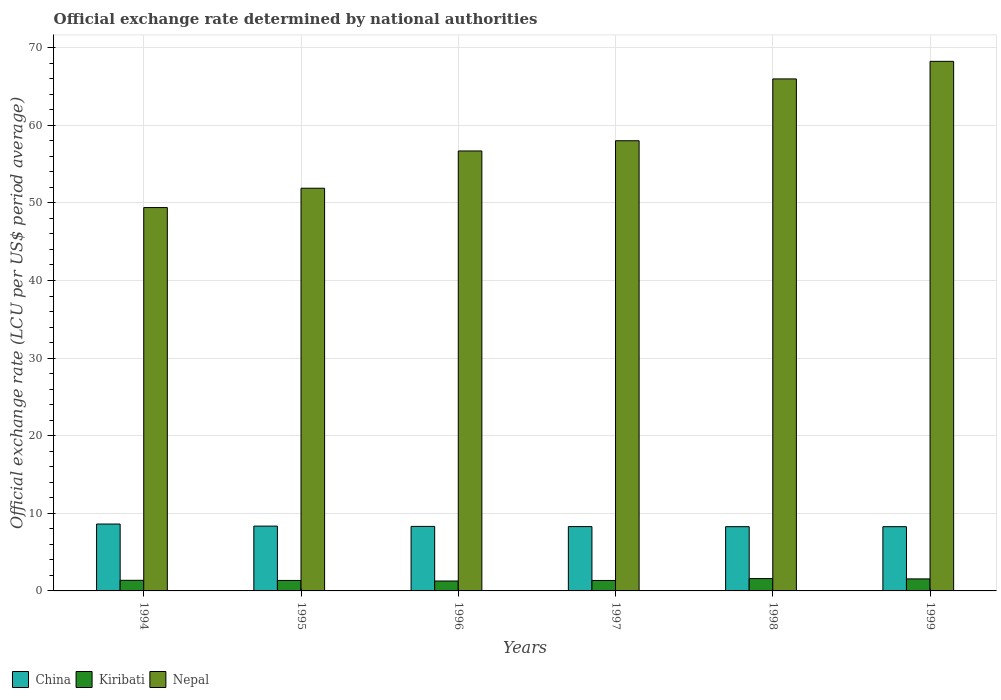How many different coloured bars are there?
Provide a succinct answer. 3. Are the number of bars on each tick of the X-axis equal?
Keep it short and to the point. Yes. How many bars are there on the 4th tick from the right?
Your answer should be very brief. 3. What is the official exchange rate in Kiribati in 1998?
Your response must be concise. 1.59. Across all years, what is the maximum official exchange rate in China?
Provide a short and direct response. 8.62. Across all years, what is the minimum official exchange rate in China?
Offer a very short reply. 8.28. In which year was the official exchange rate in Kiribati maximum?
Offer a very short reply. 1998. What is the total official exchange rate in China in the graph?
Give a very brief answer. 50.13. What is the difference between the official exchange rate in Kiribati in 1994 and that in 1998?
Give a very brief answer. -0.22. What is the difference between the official exchange rate in Kiribati in 1998 and the official exchange rate in Nepal in 1996?
Your answer should be compact. -55.1. What is the average official exchange rate in Nepal per year?
Keep it short and to the point. 58.37. In the year 1996, what is the difference between the official exchange rate in China and official exchange rate in Kiribati?
Your answer should be very brief. 7.04. What is the ratio of the official exchange rate in Nepal in 1995 to that in 1997?
Offer a terse response. 0.89. What is the difference between the highest and the second highest official exchange rate in Kiribati?
Ensure brevity in your answer.  0.04. What is the difference between the highest and the lowest official exchange rate in Kiribati?
Provide a succinct answer. 0.31. What does the 2nd bar from the left in 1994 represents?
Your answer should be compact. Kiribati. What does the 1st bar from the right in 1994 represents?
Provide a succinct answer. Nepal. Is it the case that in every year, the sum of the official exchange rate in Kiribati and official exchange rate in Nepal is greater than the official exchange rate in China?
Provide a succinct answer. Yes. How many bars are there?
Keep it short and to the point. 18. What is the difference between two consecutive major ticks on the Y-axis?
Offer a terse response. 10. Are the values on the major ticks of Y-axis written in scientific E-notation?
Provide a succinct answer. No. Does the graph contain any zero values?
Provide a short and direct response. No. Where does the legend appear in the graph?
Keep it short and to the point. Bottom left. How many legend labels are there?
Your answer should be compact. 3. What is the title of the graph?
Provide a short and direct response. Official exchange rate determined by national authorities. Does "Philippines" appear as one of the legend labels in the graph?
Make the answer very short. No. What is the label or title of the X-axis?
Offer a very short reply. Years. What is the label or title of the Y-axis?
Offer a very short reply. Official exchange rate (LCU per US$ period average). What is the Official exchange rate (LCU per US$ period average) of China in 1994?
Ensure brevity in your answer.  8.62. What is the Official exchange rate (LCU per US$ period average) of Kiribati in 1994?
Your answer should be compact. 1.37. What is the Official exchange rate (LCU per US$ period average) in Nepal in 1994?
Your answer should be very brief. 49.4. What is the Official exchange rate (LCU per US$ period average) in China in 1995?
Offer a terse response. 8.35. What is the Official exchange rate (LCU per US$ period average) in Kiribati in 1995?
Your answer should be very brief. 1.35. What is the Official exchange rate (LCU per US$ period average) in Nepal in 1995?
Offer a very short reply. 51.89. What is the Official exchange rate (LCU per US$ period average) of China in 1996?
Give a very brief answer. 8.31. What is the Official exchange rate (LCU per US$ period average) of Kiribati in 1996?
Offer a terse response. 1.28. What is the Official exchange rate (LCU per US$ period average) in Nepal in 1996?
Make the answer very short. 56.69. What is the Official exchange rate (LCU per US$ period average) in China in 1997?
Offer a terse response. 8.29. What is the Official exchange rate (LCU per US$ period average) in Kiribati in 1997?
Provide a short and direct response. 1.35. What is the Official exchange rate (LCU per US$ period average) of Nepal in 1997?
Your answer should be very brief. 58.01. What is the Official exchange rate (LCU per US$ period average) in China in 1998?
Keep it short and to the point. 8.28. What is the Official exchange rate (LCU per US$ period average) of Kiribati in 1998?
Provide a succinct answer. 1.59. What is the Official exchange rate (LCU per US$ period average) of Nepal in 1998?
Keep it short and to the point. 65.98. What is the Official exchange rate (LCU per US$ period average) in China in 1999?
Keep it short and to the point. 8.28. What is the Official exchange rate (LCU per US$ period average) in Kiribati in 1999?
Make the answer very short. 1.55. What is the Official exchange rate (LCU per US$ period average) of Nepal in 1999?
Ensure brevity in your answer.  68.24. Across all years, what is the maximum Official exchange rate (LCU per US$ period average) in China?
Keep it short and to the point. 8.62. Across all years, what is the maximum Official exchange rate (LCU per US$ period average) of Kiribati?
Make the answer very short. 1.59. Across all years, what is the maximum Official exchange rate (LCU per US$ period average) in Nepal?
Your response must be concise. 68.24. Across all years, what is the minimum Official exchange rate (LCU per US$ period average) of China?
Your answer should be compact. 8.28. Across all years, what is the minimum Official exchange rate (LCU per US$ period average) in Kiribati?
Provide a succinct answer. 1.28. Across all years, what is the minimum Official exchange rate (LCU per US$ period average) of Nepal?
Provide a succinct answer. 49.4. What is the total Official exchange rate (LCU per US$ period average) of China in the graph?
Provide a short and direct response. 50.13. What is the total Official exchange rate (LCU per US$ period average) in Kiribati in the graph?
Offer a terse response. 8.48. What is the total Official exchange rate (LCU per US$ period average) of Nepal in the graph?
Your answer should be compact. 350.2. What is the difference between the Official exchange rate (LCU per US$ period average) of China in 1994 and that in 1995?
Your response must be concise. 0.27. What is the difference between the Official exchange rate (LCU per US$ period average) of Kiribati in 1994 and that in 1995?
Offer a very short reply. 0.02. What is the difference between the Official exchange rate (LCU per US$ period average) of Nepal in 1994 and that in 1995?
Ensure brevity in your answer.  -2.49. What is the difference between the Official exchange rate (LCU per US$ period average) in China in 1994 and that in 1996?
Provide a short and direct response. 0.3. What is the difference between the Official exchange rate (LCU per US$ period average) of Kiribati in 1994 and that in 1996?
Your answer should be very brief. 0.09. What is the difference between the Official exchange rate (LCU per US$ period average) of Nepal in 1994 and that in 1996?
Give a very brief answer. -7.29. What is the difference between the Official exchange rate (LCU per US$ period average) in China in 1994 and that in 1997?
Your answer should be very brief. 0.33. What is the difference between the Official exchange rate (LCU per US$ period average) in Kiribati in 1994 and that in 1997?
Your answer should be compact. 0.02. What is the difference between the Official exchange rate (LCU per US$ period average) of Nepal in 1994 and that in 1997?
Make the answer very short. -8.61. What is the difference between the Official exchange rate (LCU per US$ period average) in China in 1994 and that in 1998?
Offer a terse response. 0.34. What is the difference between the Official exchange rate (LCU per US$ period average) of Kiribati in 1994 and that in 1998?
Offer a very short reply. -0.22. What is the difference between the Official exchange rate (LCU per US$ period average) of Nepal in 1994 and that in 1998?
Your answer should be very brief. -16.58. What is the difference between the Official exchange rate (LCU per US$ period average) of China in 1994 and that in 1999?
Offer a very short reply. 0.34. What is the difference between the Official exchange rate (LCU per US$ period average) of Kiribati in 1994 and that in 1999?
Make the answer very short. -0.18. What is the difference between the Official exchange rate (LCU per US$ period average) of Nepal in 1994 and that in 1999?
Your response must be concise. -18.84. What is the difference between the Official exchange rate (LCU per US$ period average) in China in 1995 and that in 1996?
Provide a succinct answer. 0.04. What is the difference between the Official exchange rate (LCU per US$ period average) in Kiribati in 1995 and that in 1996?
Keep it short and to the point. 0.07. What is the difference between the Official exchange rate (LCU per US$ period average) of Nepal in 1995 and that in 1996?
Provide a succinct answer. -4.8. What is the difference between the Official exchange rate (LCU per US$ period average) in China in 1995 and that in 1997?
Provide a short and direct response. 0.06. What is the difference between the Official exchange rate (LCU per US$ period average) of Kiribati in 1995 and that in 1997?
Provide a short and direct response. 0. What is the difference between the Official exchange rate (LCU per US$ period average) in Nepal in 1995 and that in 1997?
Provide a short and direct response. -6.12. What is the difference between the Official exchange rate (LCU per US$ period average) in China in 1995 and that in 1998?
Offer a terse response. 0.07. What is the difference between the Official exchange rate (LCU per US$ period average) of Kiribati in 1995 and that in 1998?
Your answer should be very brief. -0.24. What is the difference between the Official exchange rate (LCU per US$ period average) in Nepal in 1995 and that in 1998?
Offer a very short reply. -14.09. What is the difference between the Official exchange rate (LCU per US$ period average) in China in 1995 and that in 1999?
Offer a terse response. 0.07. What is the difference between the Official exchange rate (LCU per US$ period average) in Kiribati in 1995 and that in 1999?
Your response must be concise. -0.2. What is the difference between the Official exchange rate (LCU per US$ period average) of Nepal in 1995 and that in 1999?
Your answer should be compact. -16.35. What is the difference between the Official exchange rate (LCU per US$ period average) in China in 1996 and that in 1997?
Your response must be concise. 0.02. What is the difference between the Official exchange rate (LCU per US$ period average) of Kiribati in 1996 and that in 1997?
Keep it short and to the point. -0.07. What is the difference between the Official exchange rate (LCU per US$ period average) in Nepal in 1996 and that in 1997?
Ensure brevity in your answer.  -1.32. What is the difference between the Official exchange rate (LCU per US$ period average) of China in 1996 and that in 1998?
Provide a succinct answer. 0.04. What is the difference between the Official exchange rate (LCU per US$ period average) in Kiribati in 1996 and that in 1998?
Your answer should be compact. -0.31. What is the difference between the Official exchange rate (LCU per US$ period average) of Nepal in 1996 and that in 1998?
Offer a terse response. -9.28. What is the difference between the Official exchange rate (LCU per US$ period average) in China in 1996 and that in 1999?
Offer a very short reply. 0.04. What is the difference between the Official exchange rate (LCU per US$ period average) of Kiribati in 1996 and that in 1999?
Offer a terse response. -0.27. What is the difference between the Official exchange rate (LCU per US$ period average) in Nepal in 1996 and that in 1999?
Make the answer very short. -11.55. What is the difference between the Official exchange rate (LCU per US$ period average) of China in 1997 and that in 1998?
Offer a terse response. 0.01. What is the difference between the Official exchange rate (LCU per US$ period average) in Kiribati in 1997 and that in 1998?
Ensure brevity in your answer.  -0.24. What is the difference between the Official exchange rate (LCU per US$ period average) of Nepal in 1997 and that in 1998?
Your answer should be very brief. -7.97. What is the difference between the Official exchange rate (LCU per US$ period average) in China in 1997 and that in 1999?
Keep it short and to the point. 0.01. What is the difference between the Official exchange rate (LCU per US$ period average) in Kiribati in 1997 and that in 1999?
Keep it short and to the point. -0.2. What is the difference between the Official exchange rate (LCU per US$ period average) in Nepal in 1997 and that in 1999?
Your answer should be very brief. -10.23. What is the difference between the Official exchange rate (LCU per US$ period average) in China in 1998 and that in 1999?
Provide a short and direct response. 0. What is the difference between the Official exchange rate (LCU per US$ period average) in Kiribati in 1998 and that in 1999?
Offer a very short reply. 0.04. What is the difference between the Official exchange rate (LCU per US$ period average) of Nepal in 1998 and that in 1999?
Provide a short and direct response. -2.26. What is the difference between the Official exchange rate (LCU per US$ period average) in China in 1994 and the Official exchange rate (LCU per US$ period average) in Kiribati in 1995?
Offer a very short reply. 7.27. What is the difference between the Official exchange rate (LCU per US$ period average) in China in 1994 and the Official exchange rate (LCU per US$ period average) in Nepal in 1995?
Give a very brief answer. -43.27. What is the difference between the Official exchange rate (LCU per US$ period average) of Kiribati in 1994 and the Official exchange rate (LCU per US$ period average) of Nepal in 1995?
Provide a short and direct response. -50.52. What is the difference between the Official exchange rate (LCU per US$ period average) in China in 1994 and the Official exchange rate (LCU per US$ period average) in Kiribati in 1996?
Give a very brief answer. 7.34. What is the difference between the Official exchange rate (LCU per US$ period average) in China in 1994 and the Official exchange rate (LCU per US$ period average) in Nepal in 1996?
Give a very brief answer. -48.07. What is the difference between the Official exchange rate (LCU per US$ period average) of Kiribati in 1994 and the Official exchange rate (LCU per US$ period average) of Nepal in 1996?
Make the answer very short. -55.32. What is the difference between the Official exchange rate (LCU per US$ period average) of China in 1994 and the Official exchange rate (LCU per US$ period average) of Kiribati in 1997?
Offer a very short reply. 7.27. What is the difference between the Official exchange rate (LCU per US$ period average) of China in 1994 and the Official exchange rate (LCU per US$ period average) of Nepal in 1997?
Provide a short and direct response. -49.39. What is the difference between the Official exchange rate (LCU per US$ period average) of Kiribati in 1994 and the Official exchange rate (LCU per US$ period average) of Nepal in 1997?
Provide a succinct answer. -56.64. What is the difference between the Official exchange rate (LCU per US$ period average) in China in 1994 and the Official exchange rate (LCU per US$ period average) in Kiribati in 1998?
Offer a very short reply. 7.03. What is the difference between the Official exchange rate (LCU per US$ period average) in China in 1994 and the Official exchange rate (LCU per US$ period average) in Nepal in 1998?
Keep it short and to the point. -57.36. What is the difference between the Official exchange rate (LCU per US$ period average) in Kiribati in 1994 and the Official exchange rate (LCU per US$ period average) in Nepal in 1998?
Offer a very short reply. -64.61. What is the difference between the Official exchange rate (LCU per US$ period average) of China in 1994 and the Official exchange rate (LCU per US$ period average) of Kiribati in 1999?
Offer a very short reply. 7.07. What is the difference between the Official exchange rate (LCU per US$ period average) in China in 1994 and the Official exchange rate (LCU per US$ period average) in Nepal in 1999?
Make the answer very short. -59.62. What is the difference between the Official exchange rate (LCU per US$ period average) of Kiribati in 1994 and the Official exchange rate (LCU per US$ period average) of Nepal in 1999?
Your response must be concise. -66.87. What is the difference between the Official exchange rate (LCU per US$ period average) in China in 1995 and the Official exchange rate (LCU per US$ period average) in Kiribati in 1996?
Make the answer very short. 7.07. What is the difference between the Official exchange rate (LCU per US$ period average) of China in 1995 and the Official exchange rate (LCU per US$ period average) of Nepal in 1996?
Offer a very short reply. -48.34. What is the difference between the Official exchange rate (LCU per US$ period average) in Kiribati in 1995 and the Official exchange rate (LCU per US$ period average) in Nepal in 1996?
Ensure brevity in your answer.  -55.34. What is the difference between the Official exchange rate (LCU per US$ period average) in China in 1995 and the Official exchange rate (LCU per US$ period average) in Kiribati in 1997?
Provide a short and direct response. 7. What is the difference between the Official exchange rate (LCU per US$ period average) of China in 1995 and the Official exchange rate (LCU per US$ period average) of Nepal in 1997?
Provide a succinct answer. -49.66. What is the difference between the Official exchange rate (LCU per US$ period average) of Kiribati in 1995 and the Official exchange rate (LCU per US$ period average) of Nepal in 1997?
Make the answer very short. -56.66. What is the difference between the Official exchange rate (LCU per US$ period average) in China in 1995 and the Official exchange rate (LCU per US$ period average) in Kiribati in 1998?
Give a very brief answer. 6.76. What is the difference between the Official exchange rate (LCU per US$ period average) of China in 1995 and the Official exchange rate (LCU per US$ period average) of Nepal in 1998?
Offer a terse response. -57.62. What is the difference between the Official exchange rate (LCU per US$ period average) in Kiribati in 1995 and the Official exchange rate (LCU per US$ period average) in Nepal in 1998?
Your answer should be compact. -64.63. What is the difference between the Official exchange rate (LCU per US$ period average) in China in 1995 and the Official exchange rate (LCU per US$ period average) in Kiribati in 1999?
Give a very brief answer. 6.8. What is the difference between the Official exchange rate (LCU per US$ period average) of China in 1995 and the Official exchange rate (LCU per US$ period average) of Nepal in 1999?
Your answer should be very brief. -59.89. What is the difference between the Official exchange rate (LCU per US$ period average) of Kiribati in 1995 and the Official exchange rate (LCU per US$ period average) of Nepal in 1999?
Provide a short and direct response. -66.89. What is the difference between the Official exchange rate (LCU per US$ period average) of China in 1996 and the Official exchange rate (LCU per US$ period average) of Kiribati in 1997?
Give a very brief answer. 6.97. What is the difference between the Official exchange rate (LCU per US$ period average) in China in 1996 and the Official exchange rate (LCU per US$ period average) in Nepal in 1997?
Provide a short and direct response. -49.7. What is the difference between the Official exchange rate (LCU per US$ period average) of Kiribati in 1996 and the Official exchange rate (LCU per US$ period average) of Nepal in 1997?
Give a very brief answer. -56.73. What is the difference between the Official exchange rate (LCU per US$ period average) in China in 1996 and the Official exchange rate (LCU per US$ period average) in Kiribati in 1998?
Offer a terse response. 6.72. What is the difference between the Official exchange rate (LCU per US$ period average) in China in 1996 and the Official exchange rate (LCU per US$ period average) in Nepal in 1998?
Make the answer very short. -57.66. What is the difference between the Official exchange rate (LCU per US$ period average) in Kiribati in 1996 and the Official exchange rate (LCU per US$ period average) in Nepal in 1998?
Provide a succinct answer. -64.7. What is the difference between the Official exchange rate (LCU per US$ period average) in China in 1996 and the Official exchange rate (LCU per US$ period average) in Kiribati in 1999?
Make the answer very short. 6.76. What is the difference between the Official exchange rate (LCU per US$ period average) in China in 1996 and the Official exchange rate (LCU per US$ period average) in Nepal in 1999?
Offer a very short reply. -59.93. What is the difference between the Official exchange rate (LCU per US$ period average) in Kiribati in 1996 and the Official exchange rate (LCU per US$ period average) in Nepal in 1999?
Make the answer very short. -66.96. What is the difference between the Official exchange rate (LCU per US$ period average) of China in 1997 and the Official exchange rate (LCU per US$ period average) of Kiribati in 1998?
Keep it short and to the point. 6.7. What is the difference between the Official exchange rate (LCU per US$ period average) of China in 1997 and the Official exchange rate (LCU per US$ period average) of Nepal in 1998?
Provide a succinct answer. -57.69. What is the difference between the Official exchange rate (LCU per US$ period average) in Kiribati in 1997 and the Official exchange rate (LCU per US$ period average) in Nepal in 1998?
Provide a short and direct response. -64.63. What is the difference between the Official exchange rate (LCU per US$ period average) of China in 1997 and the Official exchange rate (LCU per US$ period average) of Kiribati in 1999?
Offer a terse response. 6.74. What is the difference between the Official exchange rate (LCU per US$ period average) of China in 1997 and the Official exchange rate (LCU per US$ period average) of Nepal in 1999?
Your answer should be compact. -59.95. What is the difference between the Official exchange rate (LCU per US$ period average) of Kiribati in 1997 and the Official exchange rate (LCU per US$ period average) of Nepal in 1999?
Ensure brevity in your answer.  -66.89. What is the difference between the Official exchange rate (LCU per US$ period average) in China in 1998 and the Official exchange rate (LCU per US$ period average) in Kiribati in 1999?
Your answer should be very brief. 6.73. What is the difference between the Official exchange rate (LCU per US$ period average) of China in 1998 and the Official exchange rate (LCU per US$ period average) of Nepal in 1999?
Provide a succinct answer. -59.96. What is the difference between the Official exchange rate (LCU per US$ period average) in Kiribati in 1998 and the Official exchange rate (LCU per US$ period average) in Nepal in 1999?
Ensure brevity in your answer.  -66.65. What is the average Official exchange rate (LCU per US$ period average) of China per year?
Your answer should be compact. 8.36. What is the average Official exchange rate (LCU per US$ period average) in Kiribati per year?
Provide a succinct answer. 1.41. What is the average Official exchange rate (LCU per US$ period average) of Nepal per year?
Give a very brief answer. 58.37. In the year 1994, what is the difference between the Official exchange rate (LCU per US$ period average) of China and Official exchange rate (LCU per US$ period average) of Kiribati?
Make the answer very short. 7.25. In the year 1994, what is the difference between the Official exchange rate (LCU per US$ period average) of China and Official exchange rate (LCU per US$ period average) of Nepal?
Provide a succinct answer. -40.78. In the year 1994, what is the difference between the Official exchange rate (LCU per US$ period average) in Kiribati and Official exchange rate (LCU per US$ period average) in Nepal?
Keep it short and to the point. -48.03. In the year 1995, what is the difference between the Official exchange rate (LCU per US$ period average) of China and Official exchange rate (LCU per US$ period average) of Kiribati?
Ensure brevity in your answer.  7. In the year 1995, what is the difference between the Official exchange rate (LCU per US$ period average) in China and Official exchange rate (LCU per US$ period average) in Nepal?
Ensure brevity in your answer.  -43.54. In the year 1995, what is the difference between the Official exchange rate (LCU per US$ period average) of Kiribati and Official exchange rate (LCU per US$ period average) of Nepal?
Your response must be concise. -50.54. In the year 1996, what is the difference between the Official exchange rate (LCU per US$ period average) in China and Official exchange rate (LCU per US$ period average) in Kiribati?
Offer a terse response. 7.04. In the year 1996, what is the difference between the Official exchange rate (LCU per US$ period average) of China and Official exchange rate (LCU per US$ period average) of Nepal?
Make the answer very short. -48.38. In the year 1996, what is the difference between the Official exchange rate (LCU per US$ period average) in Kiribati and Official exchange rate (LCU per US$ period average) in Nepal?
Make the answer very short. -55.41. In the year 1997, what is the difference between the Official exchange rate (LCU per US$ period average) in China and Official exchange rate (LCU per US$ period average) in Kiribati?
Your response must be concise. 6.94. In the year 1997, what is the difference between the Official exchange rate (LCU per US$ period average) in China and Official exchange rate (LCU per US$ period average) in Nepal?
Offer a very short reply. -49.72. In the year 1997, what is the difference between the Official exchange rate (LCU per US$ period average) in Kiribati and Official exchange rate (LCU per US$ period average) in Nepal?
Keep it short and to the point. -56.66. In the year 1998, what is the difference between the Official exchange rate (LCU per US$ period average) of China and Official exchange rate (LCU per US$ period average) of Kiribati?
Give a very brief answer. 6.69. In the year 1998, what is the difference between the Official exchange rate (LCU per US$ period average) of China and Official exchange rate (LCU per US$ period average) of Nepal?
Offer a terse response. -57.7. In the year 1998, what is the difference between the Official exchange rate (LCU per US$ period average) of Kiribati and Official exchange rate (LCU per US$ period average) of Nepal?
Your answer should be very brief. -64.38. In the year 1999, what is the difference between the Official exchange rate (LCU per US$ period average) of China and Official exchange rate (LCU per US$ period average) of Kiribati?
Offer a very short reply. 6.73. In the year 1999, what is the difference between the Official exchange rate (LCU per US$ period average) of China and Official exchange rate (LCU per US$ period average) of Nepal?
Provide a short and direct response. -59.96. In the year 1999, what is the difference between the Official exchange rate (LCU per US$ period average) in Kiribati and Official exchange rate (LCU per US$ period average) in Nepal?
Ensure brevity in your answer.  -66.69. What is the ratio of the Official exchange rate (LCU per US$ period average) in China in 1994 to that in 1995?
Make the answer very short. 1.03. What is the ratio of the Official exchange rate (LCU per US$ period average) in Kiribati in 1994 to that in 1995?
Your answer should be very brief. 1.01. What is the ratio of the Official exchange rate (LCU per US$ period average) of China in 1994 to that in 1996?
Provide a succinct answer. 1.04. What is the ratio of the Official exchange rate (LCU per US$ period average) of Kiribati in 1994 to that in 1996?
Your answer should be compact. 1.07. What is the ratio of the Official exchange rate (LCU per US$ period average) in Nepal in 1994 to that in 1996?
Offer a very short reply. 0.87. What is the ratio of the Official exchange rate (LCU per US$ period average) in China in 1994 to that in 1997?
Provide a short and direct response. 1.04. What is the ratio of the Official exchange rate (LCU per US$ period average) of Kiribati in 1994 to that in 1997?
Make the answer very short. 1.02. What is the ratio of the Official exchange rate (LCU per US$ period average) of Nepal in 1994 to that in 1997?
Offer a very short reply. 0.85. What is the ratio of the Official exchange rate (LCU per US$ period average) in China in 1994 to that in 1998?
Provide a short and direct response. 1.04. What is the ratio of the Official exchange rate (LCU per US$ period average) of Kiribati in 1994 to that in 1998?
Offer a terse response. 0.86. What is the ratio of the Official exchange rate (LCU per US$ period average) of Nepal in 1994 to that in 1998?
Make the answer very short. 0.75. What is the ratio of the Official exchange rate (LCU per US$ period average) in China in 1994 to that in 1999?
Offer a terse response. 1.04. What is the ratio of the Official exchange rate (LCU per US$ period average) in Kiribati in 1994 to that in 1999?
Keep it short and to the point. 0.88. What is the ratio of the Official exchange rate (LCU per US$ period average) in Nepal in 1994 to that in 1999?
Your answer should be compact. 0.72. What is the ratio of the Official exchange rate (LCU per US$ period average) of China in 1995 to that in 1996?
Provide a short and direct response. 1. What is the ratio of the Official exchange rate (LCU per US$ period average) of Kiribati in 1995 to that in 1996?
Your response must be concise. 1.06. What is the ratio of the Official exchange rate (LCU per US$ period average) in Nepal in 1995 to that in 1996?
Your answer should be compact. 0.92. What is the ratio of the Official exchange rate (LCU per US$ period average) in China in 1995 to that in 1997?
Make the answer very short. 1.01. What is the ratio of the Official exchange rate (LCU per US$ period average) of Nepal in 1995 to that in 1997?
Your response must be concise. 0.89. What is the ratio of the Official exchange rate (LCU per US$ period average) of China in 1995 to that in 1998?
Your answer should be compact. 1.01. What is the ratio of the Official exchange rate (LCU per US$ period average) in Kiribati in 1995 to that in 1998?
Your answer should be very brief. 0.85. What is the ratio of the Official exchange rate (LCU per US$ period average) of Nepal in 1995 to that in 1998?
Offer a terse response. 0.79. What is the ratio of the Official exchange rate (LCU per US$ period average) of China in 1995 to that in 1999?
Provide a short and direct response. 1.01. What is the ratio of the Official exchange rate (LCU per US$ period average) of Kiribati in 1995 to that in 1999?
Keep it short and to the point. 0.87. What is the ratio of the Official exchange rate (LCU per US$ period average) in Nepal in 1995 to that in 1999?
Your answer should be very brief. 0.76. What is the ratio of the Official exchange rate (LCU per US$ period average) of China in 1996 to that in 1997?
Provide a succinct answer. 1. What is the ratio of the Official exchange rate (LCU per US$ period average) of Kiribati in 1996 to that in 1997?
Your response must be concise. 0.95. What is the ratio of the Official exchange rate (LCU per US$ period average) of Nepal in 1996 to that in 1997?
Provide a succinct answer. 0.98. What is the ratio of the Official exchange rate (LCU per US$ period average) in China in 1996 to that in 1998?
Make the answer very short. 1. What is the ratio of the Official exchange rate (LCU per US$ period average) in Kiribati in 1996 to that in 1998?
Keep it short and to the point. 0.8. What is the ratio of the Official exchange rate (LCU per US$ period average) of Nepal in 1996 to that in 1998?
Offer a terse response. 0.86. What is the ratio of the Official exchange rate (LCU per US$ period average) of China in 1996 to that in 1999?
Your answer should be compact. 1. What is the ratio of the Official exchange rate (LCU per US$ period average) in Kiribati in 1996 to that in 1999?
Provide a succinct answer. 0.82. What is the ratio of the Official exchange rate (LCU per US$ period average) in Nepal in 1996 to that in 1999?
Offer a terse response. 0.83. What is the ratio of the Official exchange rate (LCU per US$ period average) of Kiribati in 1997 to that in 1998?
Ensure brevity in your answer.  0.85. What is the ratio of the Official exchange rate (LCU per US$ period average) in Nepal in 1997 to that in 1998?
Your answer should be very brief. 0.88. What is the ratio of the Official exchange rate (LCU per US$ period average) in China in 1997 to that in 1999?
Your answer should be very brief. 1. What is the ratio of the Official exchange rate (LCU per US$ period average) of Kiribati in 1997 to that in 1999?
Give a very brief answer. 0.87. What is the ratio of the Official exchange rate (LCU per US$ period average) in Nepal in 1997 to that in 1999?
Give a very brief answer. 0.85. What is the ratio of the Official exchange rate (LCU per US$ period average) in Nepal in 1998 to that in 1999?
Offer a terse response. 0.97. What is the difference between the highest and the second highest Official exchange rate (LCU per US$ period average) in China?
Provide a succinct answer. 0.27. What is the difference between the highest and the second highest Official exchange rate (LCU per US$ period average) in Kiribati?
Make the answer very short. 0.04. What is the difference between the highest and the second highest Official exchange rate (LCU per US$ period average) of Nepal?
Offer a terse response. 2.26. What is the difference between the highest and the lowest Official exchange rate (LCU per US$ period average) in China?
Provide a succinct answer. 0.34. What is the difference between the highest and the lowest Official exchange rate (LCU per US$ period average) of Kiribati?
Your response must be concise. 0.31. What is the difference between the highest and the lowest Official exchange rate (LCU per US$ period average) of Nepal?
Keep it short and to the point. 18.84. 